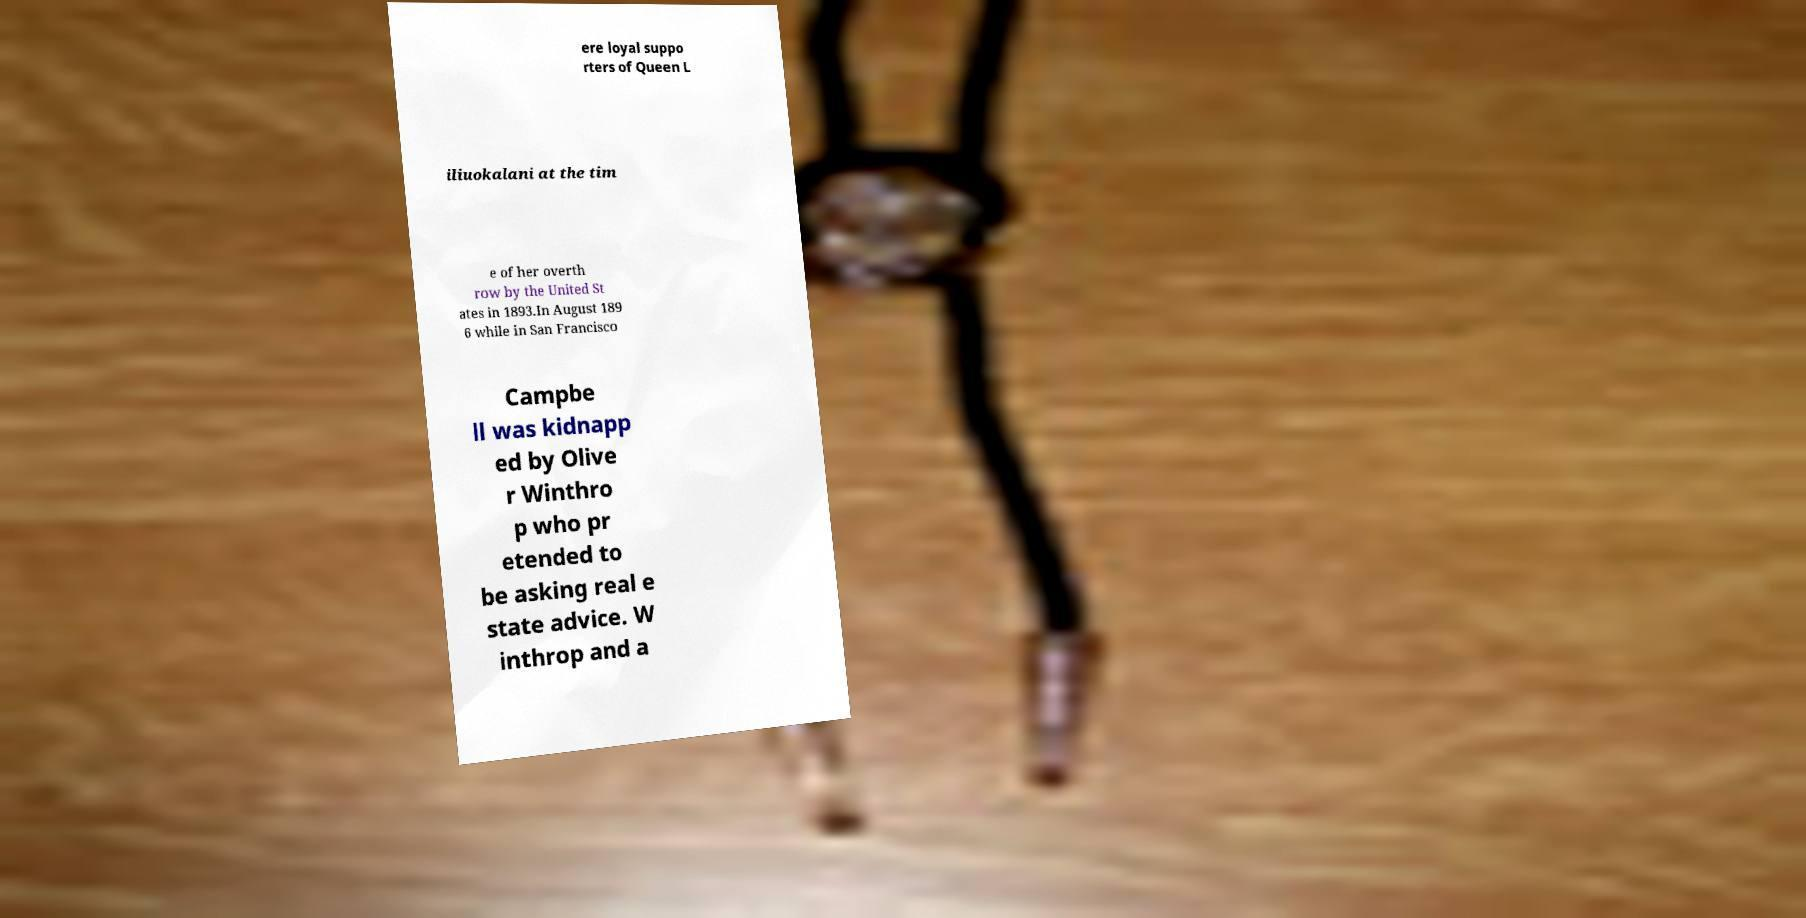What messages or text are displayed in this image? I need them in a readable, typed format. ere loyal suppo rters of Queen L iliuokalani at the tim e of her overth row by the United St ates in 1893.In August 189 6 while in San Francisco Campbe ll was kidnapp ed by Olive r Winthro p who pr etended to be asking real e state advice. W inthrop and a 